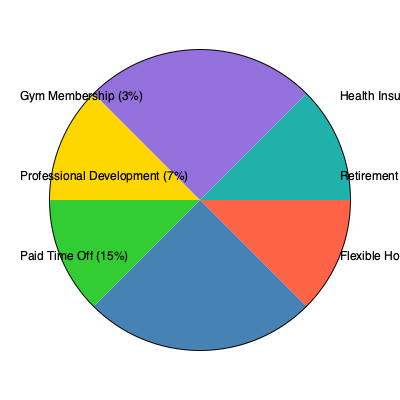Based on the pie chart showing employee preferences for various benefits, which two benefits combined account for more than half of the total preferences? What is their combined percentage? To solve this question, we need to follow these steps:

1. Identify the two largest segments in the pie chart.
2. Add their percentages together.
3. Check if the sum exceeds 50%.

Looking at the pie chart:

1. The two largest segments are:
   - Health Insurance: 30%
   - Retirement Plan: 25%

2. Adding these percentages:
   $30\% + 25\% = 55\%$

3. Checking if the sum exceeds 50%:
   55% is indeed greater than 50%

Therefore, Health Insurance and Retirement Plan combined account for more than half of the total preferences, with a combined percentage of 55%.

This information is crucial for a start-up founder creating a benefits package, as it highlights the two most valued benefits among potential employees.
Answer: Health Insurance and Retirement Plan, 55% 